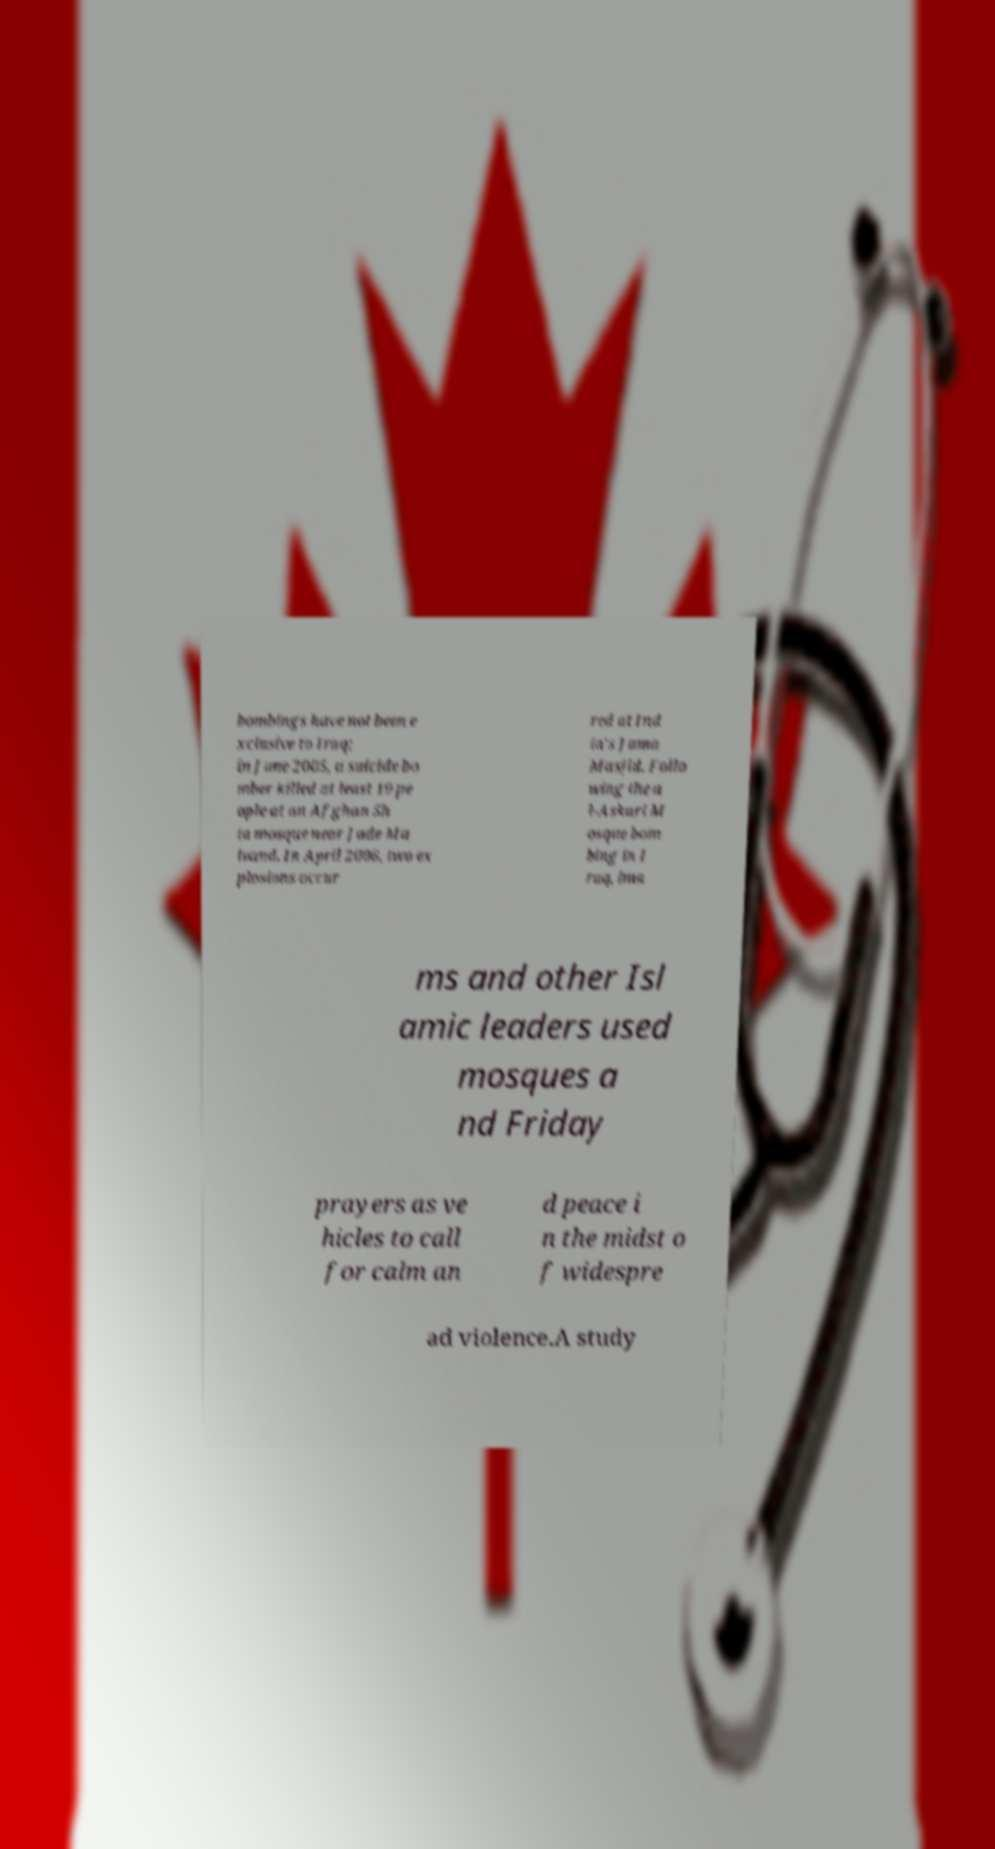Can you accurately transcribe the text from the provided image for me? bombings have not been e xclusive to Iraq; in June 2005, a suicide bo mber killed at least 19 pe ople at an Afghan Sh ia mosque near Jade Ma ivand. In April 2006, two ex plosions occur red at Ind ia's Jama Masjid. Follo wing the a l-Askari M osque bom bing in I raq, ima ms and other Isl amic leaders used mosques a nd Friday prayers as ve hicles to call for calm an d peace i n the midst o f widespre ad violence.A study 